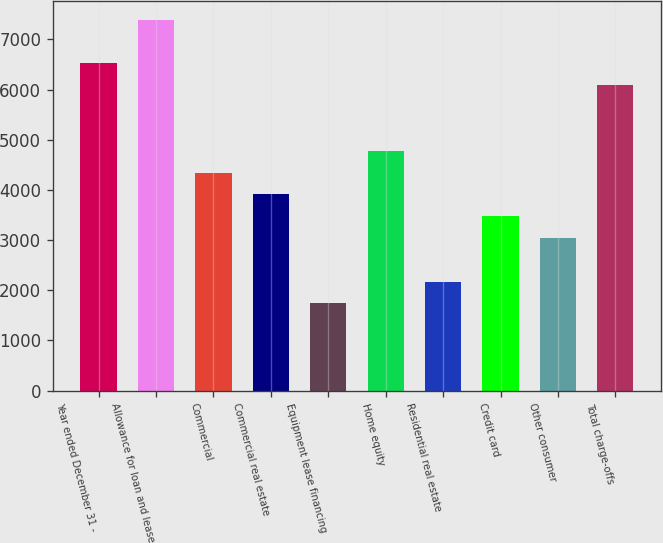Convert chart to OTSL. <chart><loc_0><loc_0><loc_500><loc_500><bar_chart><fcel>Year ended December 31 -<fcel>Allowance for loan and lease<fcel>Commercial<fcel>Commercial real estate<fcel>Equipment lease financing<fcel>Home equity<fcel>Residential real estate<fcel>Credit card<fcel>Other consumer<fcel>Total charge-offs<nl><fcel>6520.16<fcel>7389.44<fcel>4346.96<fcel>3912.32<fcel>1739.12<fcel>4781.6<fcel>2173.76<fcel>3477.68<fcel>3043.04<fcel>6085.52<nl></chart> 